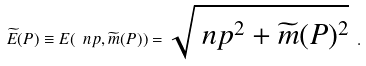Convert formula to latex. <formula><loc_0><loc_0><loc_500><loc_500>\widetilde { E } ( P ) \equiv E ( \ n p , \widetilde { m } ( P ) ) = \sqrt { \ n p ^ { 2 } + \widetilde { m } ( P ) ^ { 2 } } \ .</formula> 